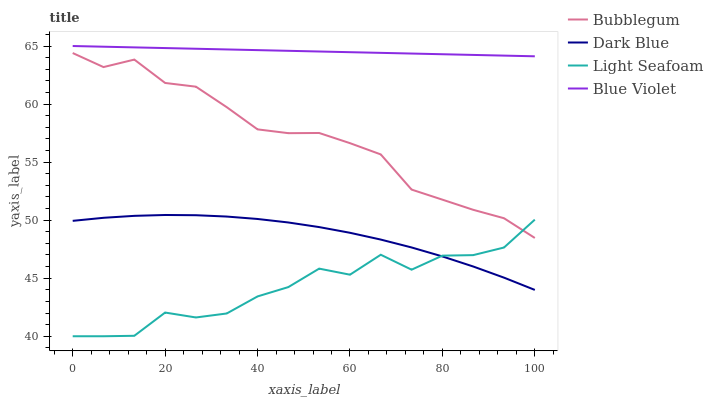Does Light Seafoam have the minimum area under the curve?
Answer yes or no. Yes. Does Blue Violet have the maximum area under the curve?
Answer yes or no. Yes. Does Blue Violet have the minimum area under the curve?
Answer yes or no. No. Does Light Seafoam have the maximum area under the curve?
Answer yes or no. No. Is Blue Violet the smoothest?
Answer yes or no. Yes. Is Light Seafoam the roughest?
Answer yes or no. Yes. Is Light Seafoam the smoothest?
Answer yes or no. No. Is Blue Violet the roughest?
Answer yes or no. No. Does Blue Violet have the lowest value?
Answer yes or no. No. Does Light Seafoam have the highest value?
Answer yes or no. No. Is Dark Blue less than Blue Violet?
Answer yes or no. Yes. Is Blue Violet greater than Bubblegum?
Answer yes or no. Yes. Does Dark Blue intersect Blue Violet?
Answer yes or no. No. 